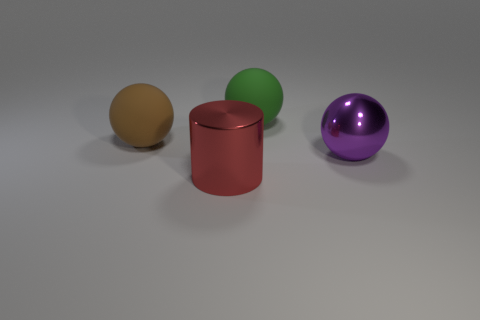Add 1 blocks. How many objects exist? 5 Subtract all balls. How many objects are left? 1 Subtract all large yellow blocks. Subtract all big shiny spheres. How many objects are left? 3 Add 1 large red things. How many large red things are left? 2 Add 2 big brown matte spheres. How many big brown matte spheres exist? 3 Subtract 1 red cylinders. How many objects are left? 3 